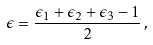Convert formula to latex. <formula><loc_0><loc_0><loc_500><loc_500>\epsilon = \frac { \epsilon _ { 1 } + \epsilon _ { 2 } + \epsilon _ { 3 } - 1 } { 2 } \, ,</formula> 